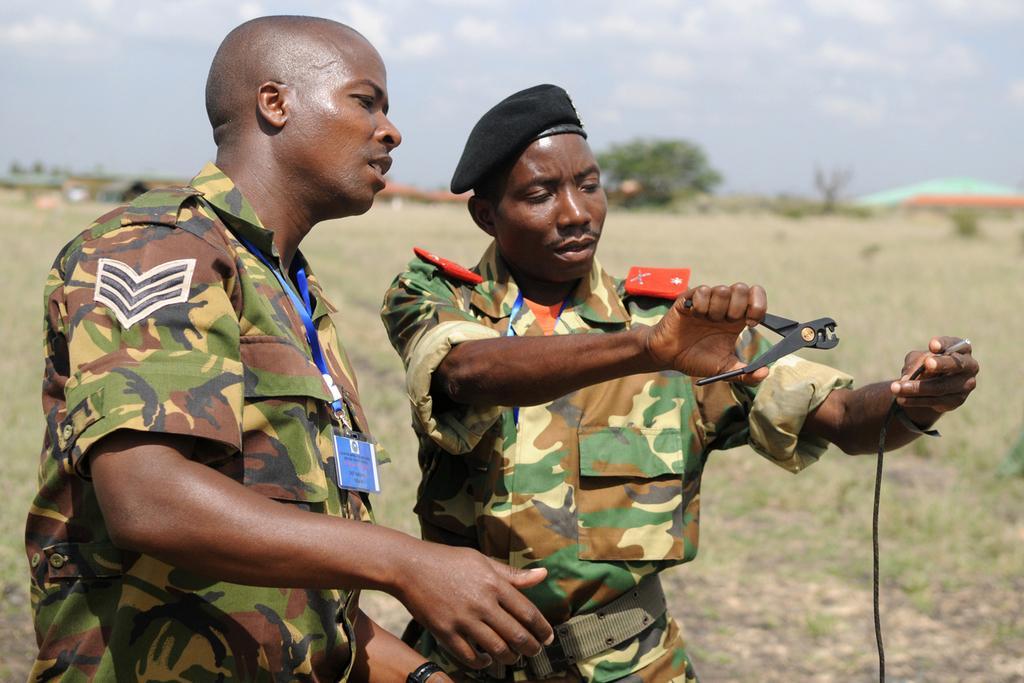Describe this image in one or two sentences. In this image in the front there are persons standing. The man on the right side is standing and holding a wire and a cutting plier in his hand. In the background there is grass on the ground and there is a tree and the sky is cloudy. 